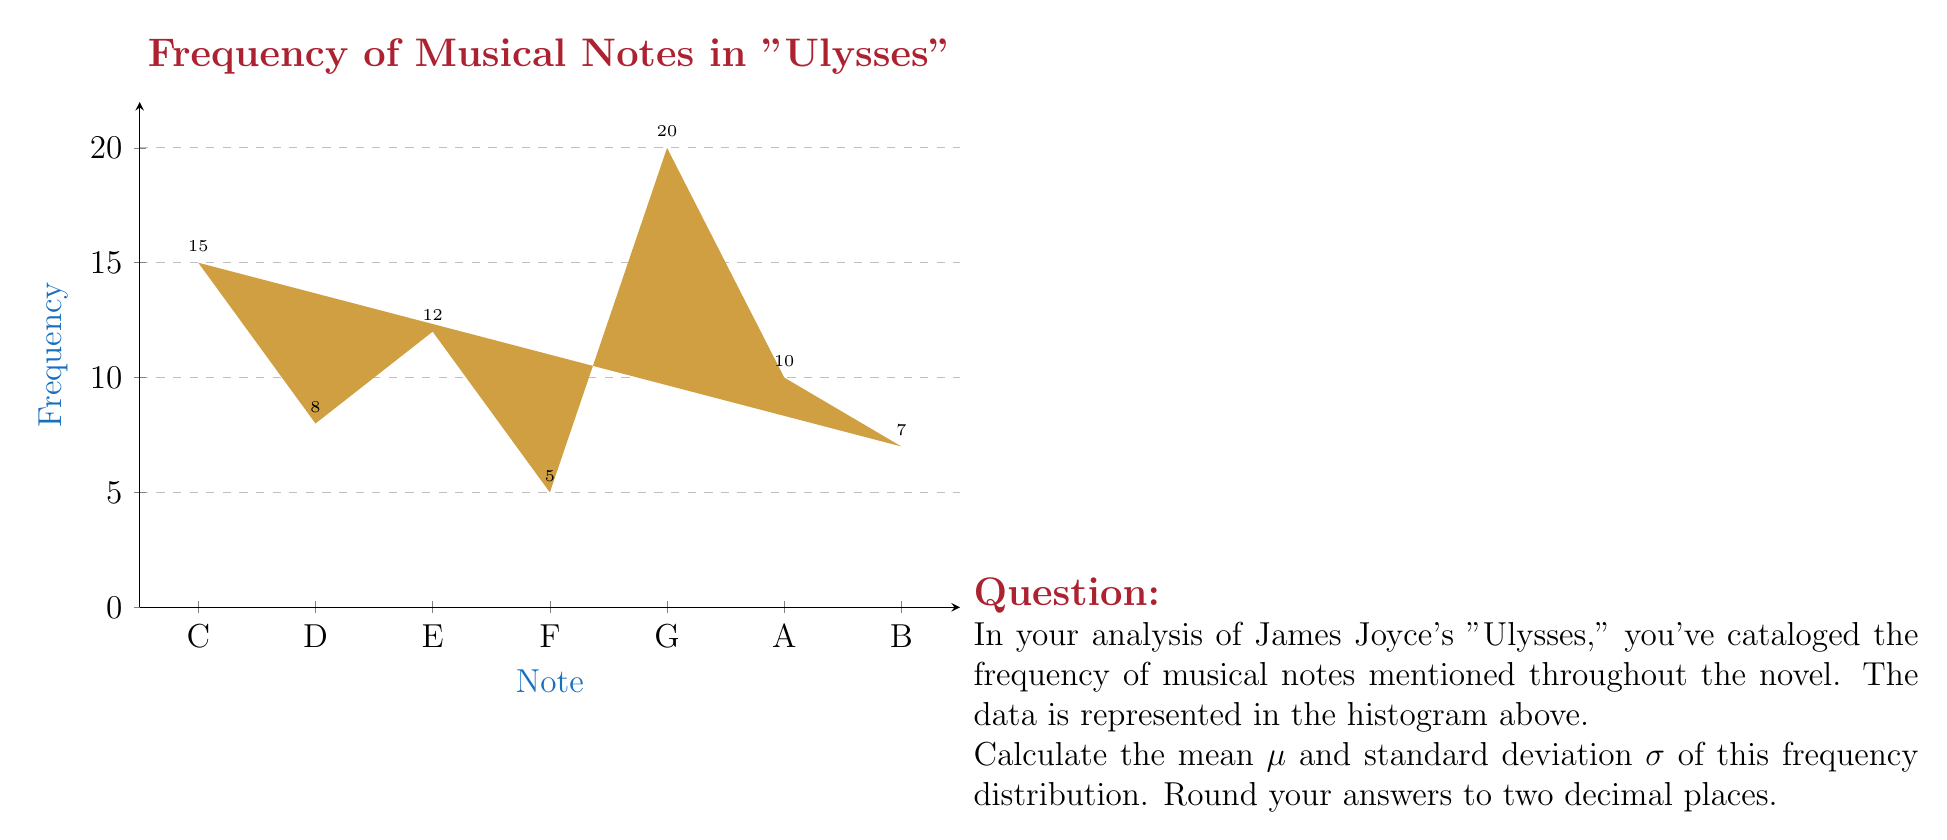Solve this math problem. To solve this problem, we'll follow these steps:

1) First, let's calculate the mean $\mu$. The formula for the mean is:

   $$\mu = \frac{\sum_{i=1}^{n} x_i f_i}{\sum_{i=1}^{n} f_i}$$

   where $x_i$ are the values (in this case, we'll use 1 to 7 for the seven notes) and $f_i$ are the frequencies.

2) Let's calculate the numerator and denominator:

   Numerator: $1(15) + 2(8) + 3(12) + 4(5) + 5(20) + 6(10) + 7(7) = 277$
   Denominator: $15 + 8 + 12 + 5 + 20 + 10 + 7 = 77$

3) Now we can calculate the mean:

   $$\mu = \frac{277}{77} \approx 3.60$$

4) Next, let's calculate the standard deviation $\sigma$. The formula is:

   $$\sigma = \sqrt{\frac{\sum_{i=1}^{n} (x_i - \mu)^2 f_i}{\sum_{i=1}^{n} f_i}}$$

5) Let's calculate the numerator:

   $(1-3.60)^2(15) + (2-3.60)^2(8) + (3-3.60)^2(12) + (4-3.60)^2(5) + (5-3.60)^2(20) + (6-3.60)^2(10) + (7-3.60)^2(7)$
   
   $= 102.96 + 20.48 + 4.32 + 0.80 + 39.20 + 57.60 + 81.62 = 306.98$

6) Now we can calculate the standard deviation:

   $$\sigma = \sqrt{\frac{306.98}{77}} \approx 1.99$$

7) Rounding both results to two decimal places:

   $\mu \approx 3.60$
   $\sigma \approx 1.99$
Answer: $\mu = 3.60$, $\sigma = 1.99$ 